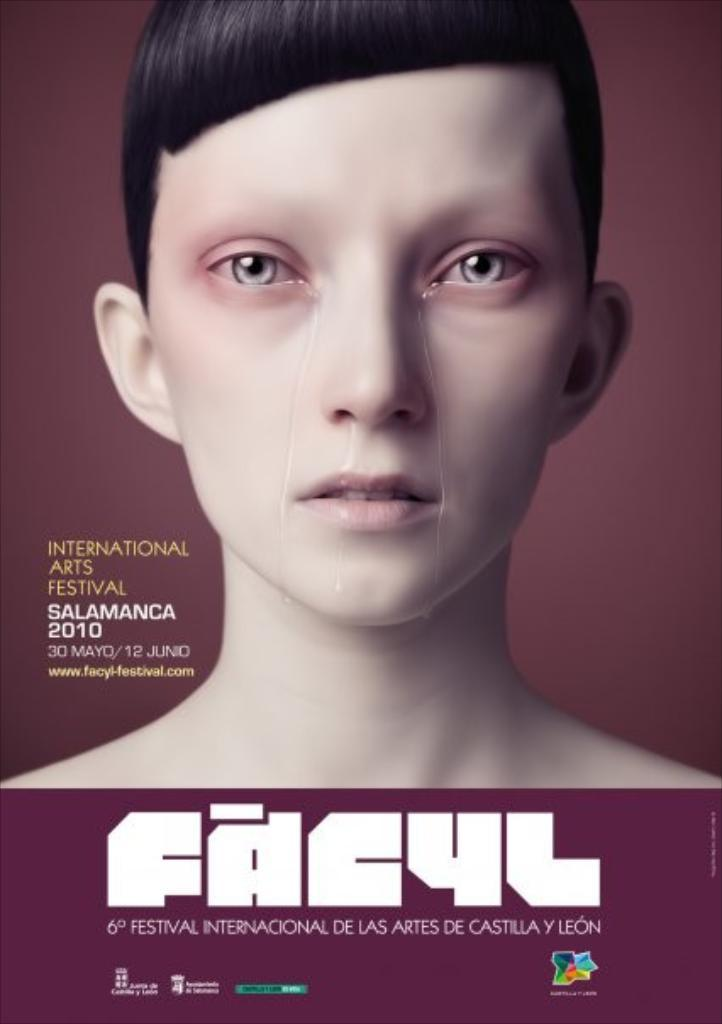What is present on the poster in the image? There is a poster in the image, which contains text and an image of a person. What type of plants can be seen growing on the person in the image? There are no plants visible on the person in the image; the poster only contains an image of a person and text. 